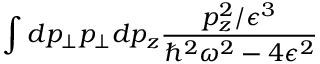Convert formula to latex. <formula><loc_0><loc_0><loc_500><loc_500>\int d p _ { \bot } p _ { \bot } d p _ { z } \frac { p _ { z } ^ { 2 } / \epsilon ^ { 3 } } { \hbar { ^ } { 2 } \omega ^ { 2 } - 4 \epsilon ^ { 2 } }</formula> 